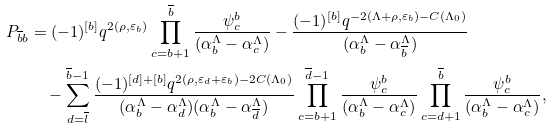<formula> <loc_0><loc_0><loc_500><loc_500>P _ { \overline { b } b } & = ( - 1 ) ^ { [ b ] } q ^ { 2 ( \rho , \varepsilon _ { b } ) } \prod _ { c = b + 1 } ^ { \overline { b } } \frac { \psi ^ { b } _ { c } } { ( \alpha _ { b } ^ { \Lambda } - \alpha _ { c } ^ { \Lambda } ) } - \frac { ( - 1 ) ^ { [ b ] } q ^ { - 2 ( \Lambda + \rho , \varepsilon _ { b } ) - C ( \Lambda _ { 0 } ) } } { ( \alpha _ { b } ^ { \Lambda } - \alpha _ { \overline { b } } ^ { \Lambda } ) } \\ & \quad - \sum _ { d = \overline { l } } ^ { \overline { b } - 1 } \frac { ( - 1 ) ^ { [ d ] + [ b ] } q ^ { 2 ( \rho , \varepsilon _ { d } + \varepsilon _ { b } ) - 2 C ( \Lambda _ { 0 } ) } } { ( \alpha _ { b } ^ { \Lambda } - \alpha _ { d } ^ { \Lambda } ) ( \alpha _ { b } ^ { \Lambda } - \alpha _ { \overline { d } } ^ { \Lambda } ) } \prod _ { c = b + 1 } ^ { \overline { d } - 1 } \frac { \psi ^ { b } _ { c } } { ( \alpha _ { b } ^ { \Lambda } - \alpha _ { c } ^ { \Lambda } ) } \prod _ { c = d + 1 } ^ { \overline { b } } \frac { \psi ^ { b } _ { c } } { ( \alpha _ { b } ^ { \Lambda } - \alpha _ { c } ^ { \Lambda } ) } ,</formula> 